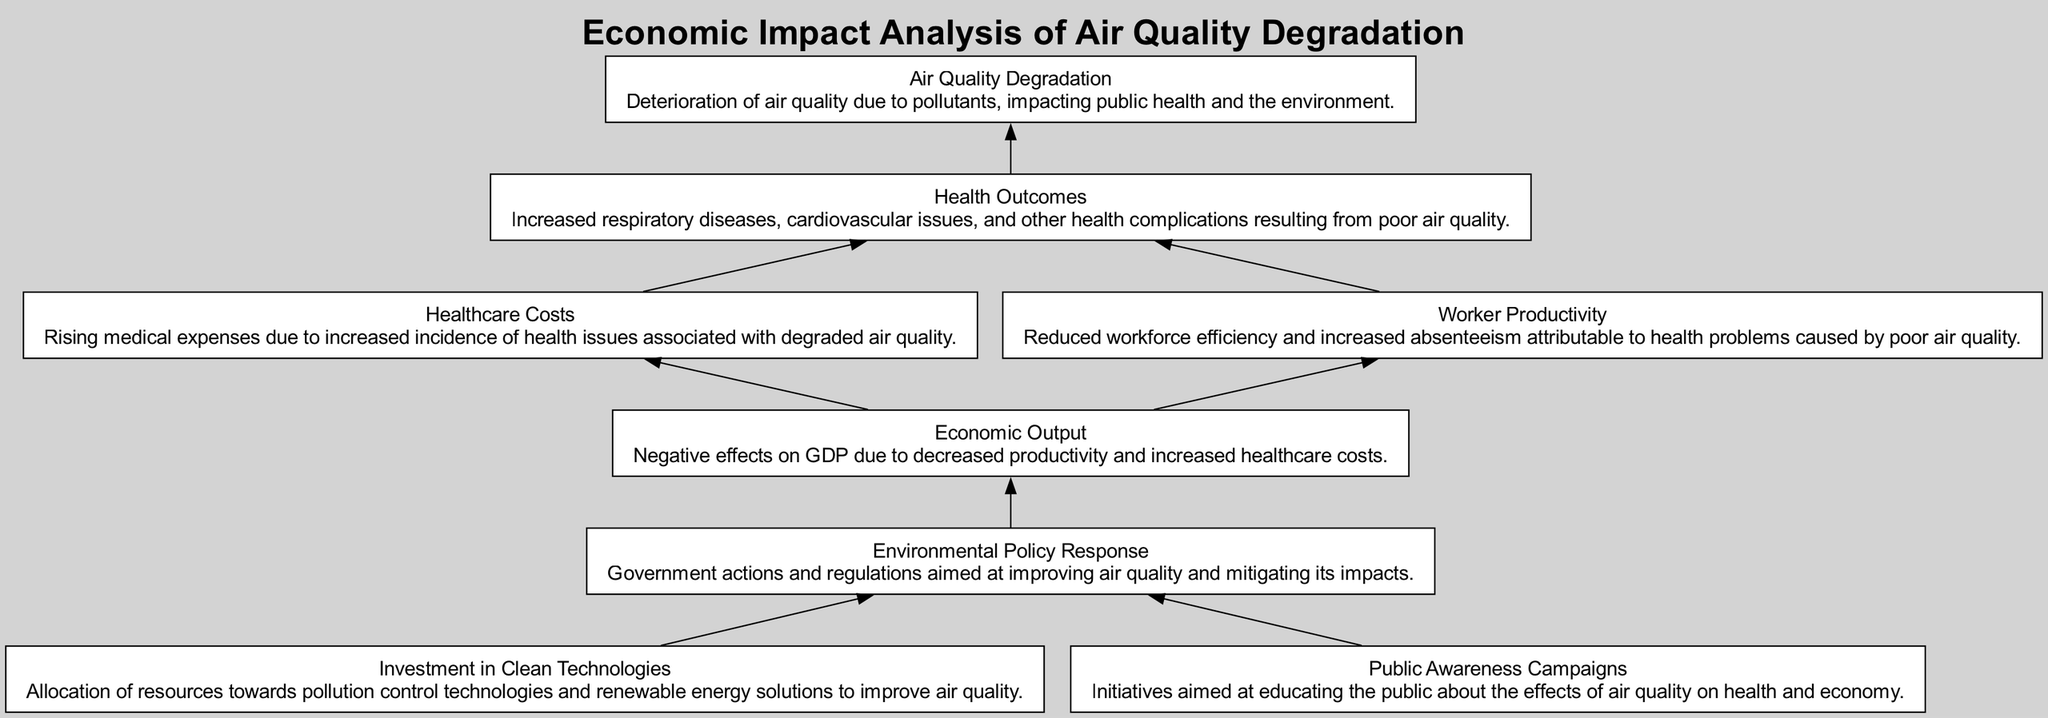What is the primary factor leading to health complications? The diagram indicates that "Air Quality Degradation" is the root cause affecting public health, leading to "Health Outcomes" such as respiratory diseases and cardiovascular issues. Therefore, the primary factor is air quality degradation.
Answer: Air Quality Degradation How many nodes are there in the diagram? By counting each distinct element listed within the diagram, there are a total of eight nodes representing various aspects of economic impact analysis of air quality degradation.
Answer: Eight What do increased healthcare costs negatively impact? The flow chart illustrates that enhanced healthcare costs resulting from poor health outcomes subsequently affect "Economic Output." Therefore, the negative impact of these rising costs is on economic output.
Answer: Economic Output Which elements contribute to environmental policy response? The diagram shows "Investment in Clean Technologies" and "Public Awareness Campaigns" as the factors leading to "Environmental Policy Response." Thus, both of these elements contribute to the policy response.
Answer: Investment in Clean Technologies and Public Awareness Campaigns What is the relationship between worker productivity and healthcare costs? The flow chart indicates that both "Worker Productivity" and "Healthcare Costs" are influenced by "Health Outcomes." Hence, the relationship is that both factors (worker productivity and healthcare costs) stem from health outcomes.
Answer: Health Outcomes What is the overall economic consequence of air quality degradation? The diagram illustrates that the overall consequence includes negative effects on GDP caused by decreased productivity and upward healthcare costs stemming from health complications. Therefore, the overall economic consequence is a negative effect on GDP.
Answer: Negative effect on GDP How do environmental policies affect economic output? The diagram demonstrates that "Environmental Policy Response" directly influences "Economic Output" by potentially improving air quality and, hence, economic factors. The effect is a positive contribution to economic output.
Answer: Positive contribution to Economic Output What is a possible long-term solution indicated in the diagram? The diagram suggests that "Investment in Clean Technologies" serves as a long-term solution for addressing air quality issues leading to better health outcomes and economic stability. Thus, investment in clean technologies represents a potential solution.
Answer: Investment in Clean Technologies 